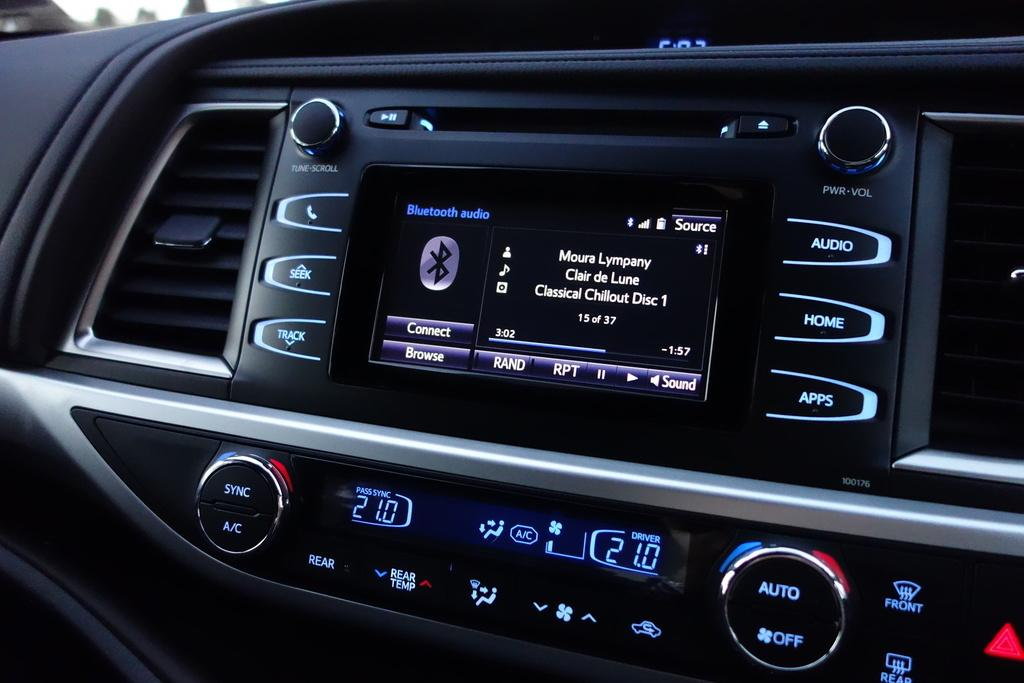What is the main subject of the image? The main subject of the image is a car music system. What can you tell me about the color of the car music system? The car music system is black in color. Are there any controls or features visible on the car music system? Yes, there are buttons on the car music system. What type of cake is being served on the car music system in the image? There is no cake present in the image; the main subject is a car music system. Can you see any bushes or plants growing around the car music system in the image? The image does not show any bushes or plants; it only features a car music system. 